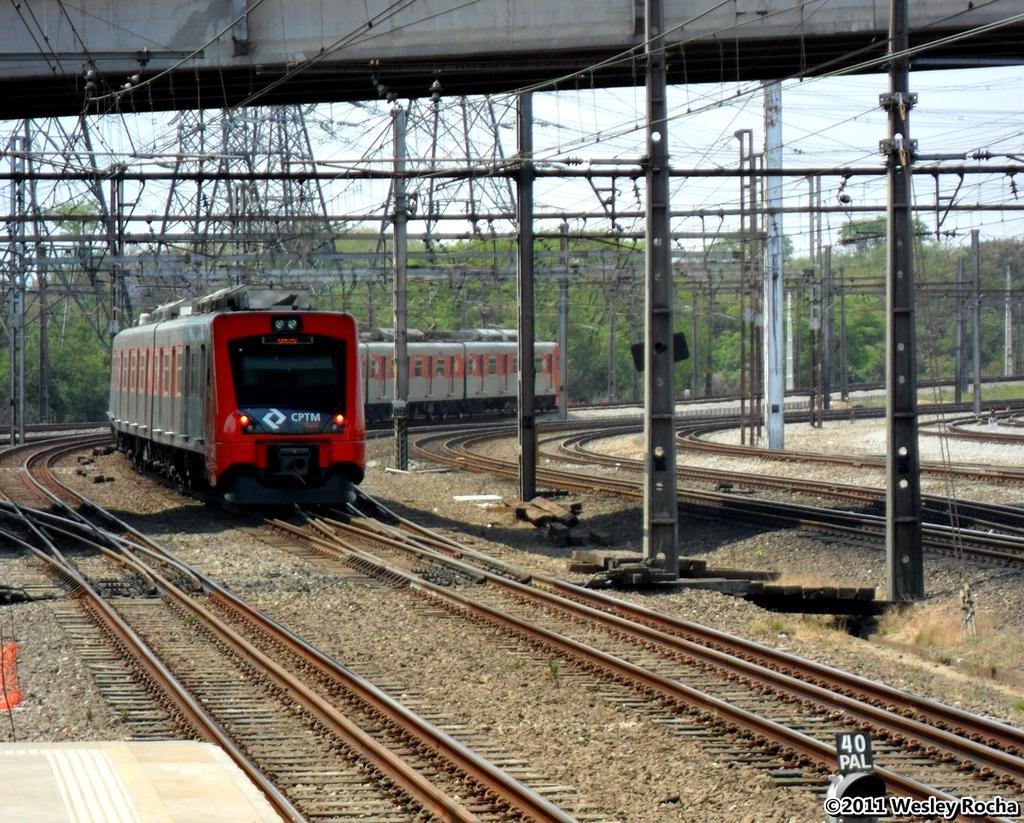Please provide a concise description of this image. In the center of the image there is a train on the railway track. On top of the image there are metal rods, wires. There are poles. In the background of the image there are trees and sky. There is some text on the right side of the image. 